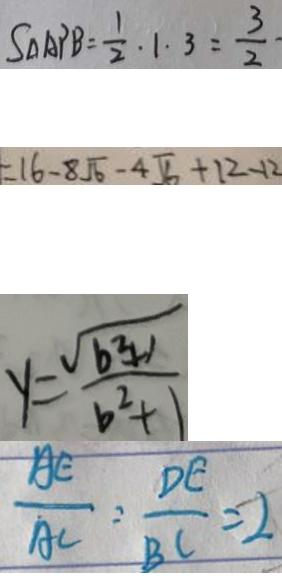<formula> <loc_0><loc_0><loc_500><loc_500>S _ { \Delta A P B } = \frac { 1 } { 2 } \cdot 1 \cdot 3 = \frac { 3 } { 2 } \cdot 
 = 1 6 - 8 \sqrt { 6 } - 4 \sqrt { 6 } + 1 2 - 1 2 
 y = \frac { \sqrt { b ^ { 2 } + 1 } } { b ^ { 2 } + 1 } 
 \frac { A E } { A C } = \frac { D E } { B C } = 2</formula> 